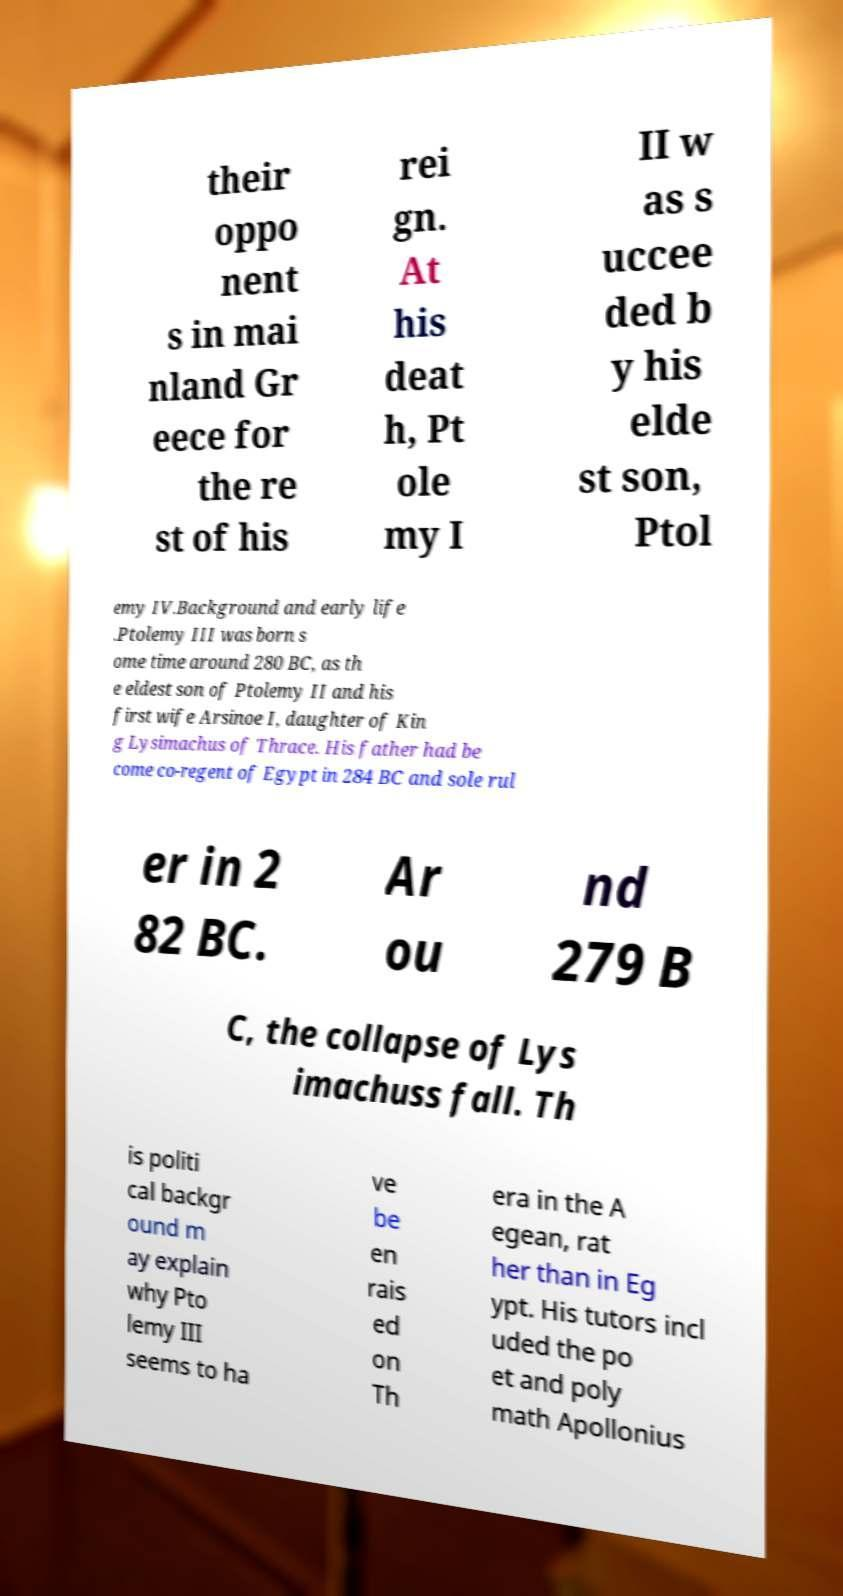Please read and relay the text visible in this image. What does it say? their oppo nent s in mai nland Gr eece for the re st of his rei gn. At his deat h, Pt ole my I II w as s uccee ded b y his elde st son, Ptol emy IV.Background and early life .Ptolemy III was born s ome time around 280 BC, as th e eldest son of Ptolemy II and his first wife Arsinoe I, daughter of Kin g Lysimachus of Thrace. His father had be come co-regent of Egypt in 284 BC and sole rul er in 2 82 BC. Ar ou nd 279 B C, the collapse of Lys imachuss fall. Th is politi cal backgr ound m ay explain why Pto lemy III seems to ha ve be en rais ed on Th era in the A egean, rat her than in Eg ypt. His tutors incl uded the po et and poly math Apollonius 